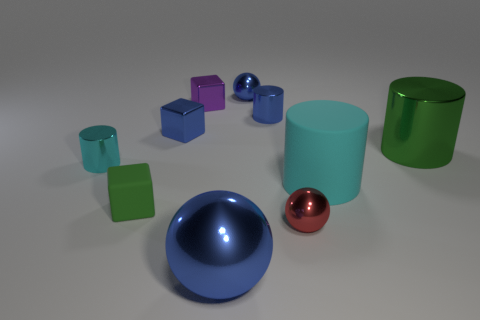Which objects in this image could represent a modern art sculpture when combined? Combining the sleek cyan cylinder, the reflective blue sphere, and the small purple cube could result in an abstract modern art sculpture. Their distinct shapes and colors would play off each other to create a visually stimulating and harmonious composition. 